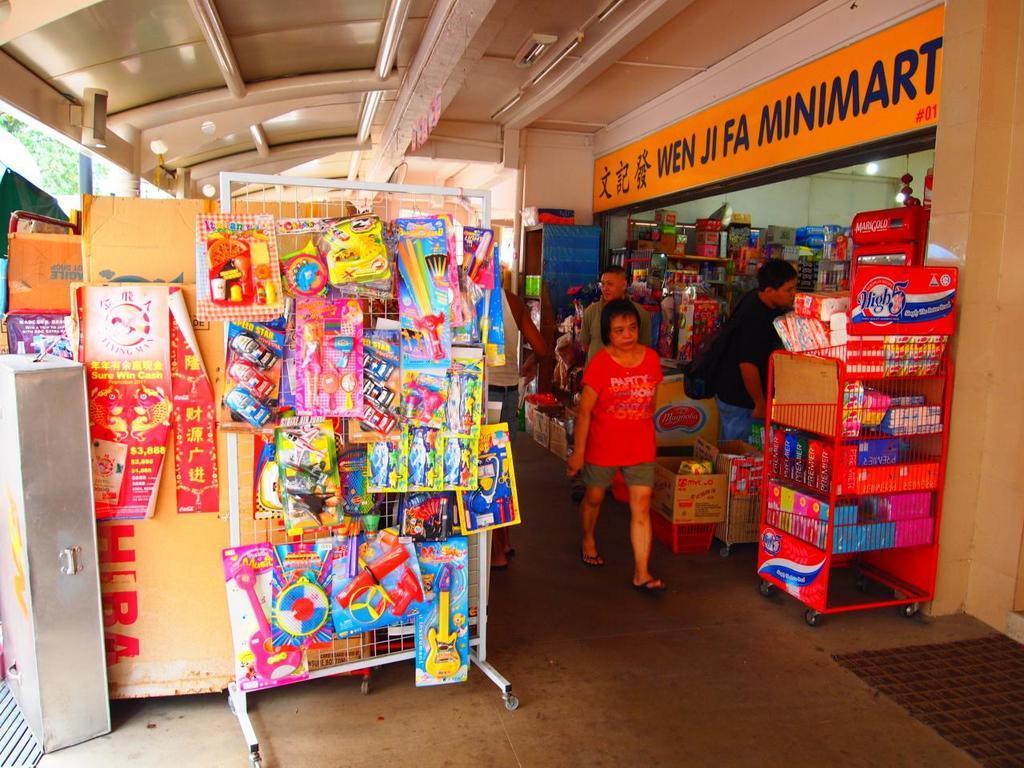How would you summarize this image in a sentence or two? Here is a woman walking and few people standing. This is a shop. These are the toys, which are changing to an iron grill. This looks like a cardboard box. I can see a name board attached to the wall. This is the rack with few objects in it. Here is the roof. 